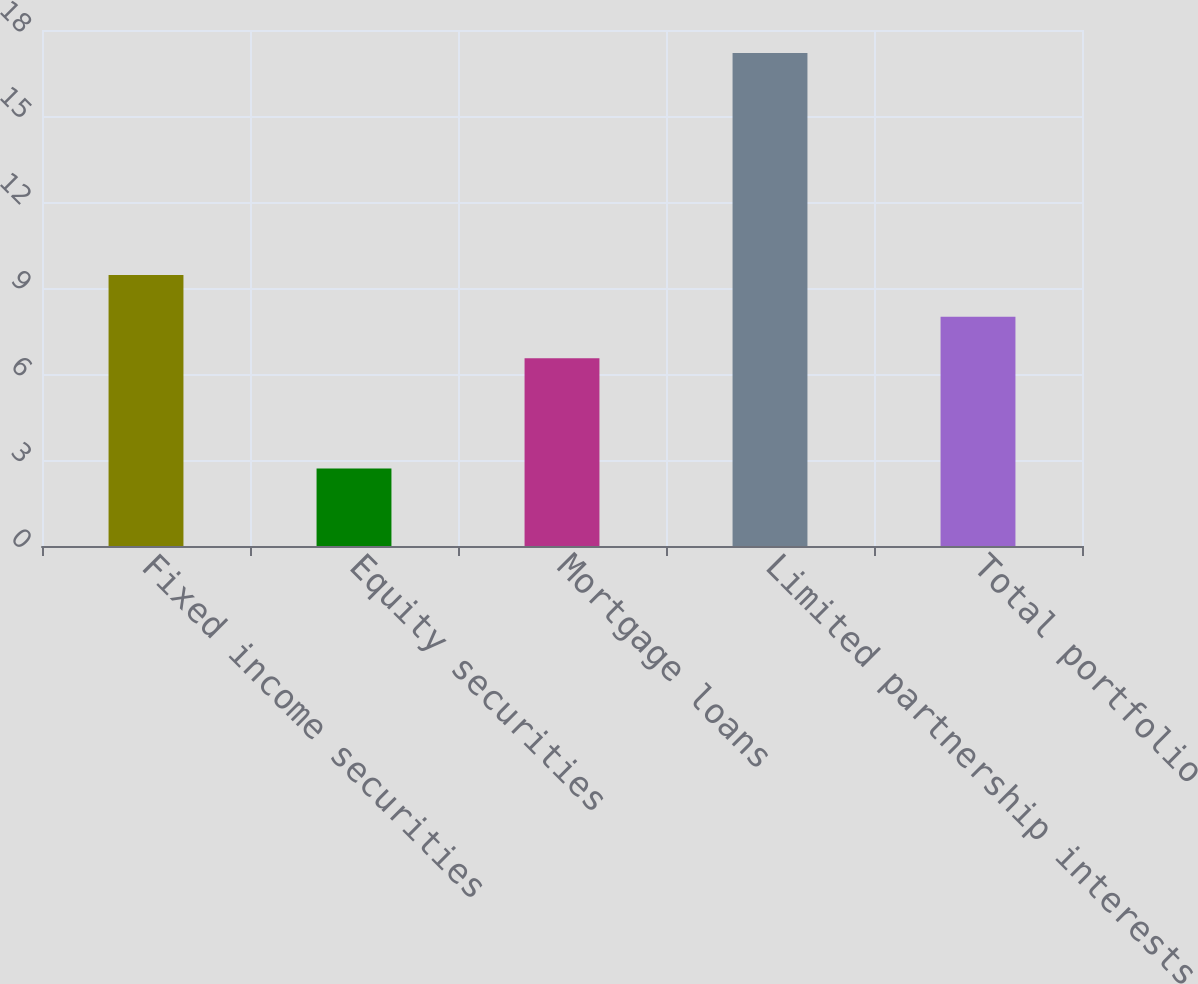Convert chart to OTSL. <chart><loc_0><loc_0><loc_500><loc_500><bar_chart><fcel>Fixed income securities<fcel>Equity securities<fcel>Mortgage loans<fcel>Limited partnership interests<fcel>Total portfolio<nl><fcel>9.45<fcel>2.7<fcel>6.55<fcel>17.2<fcel>8<nl></chart> 